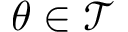Convert formula to latex. <formula><loc_0><loc_0><loc_500><loc_500>\theta \in \mathcal { T }</formula> 